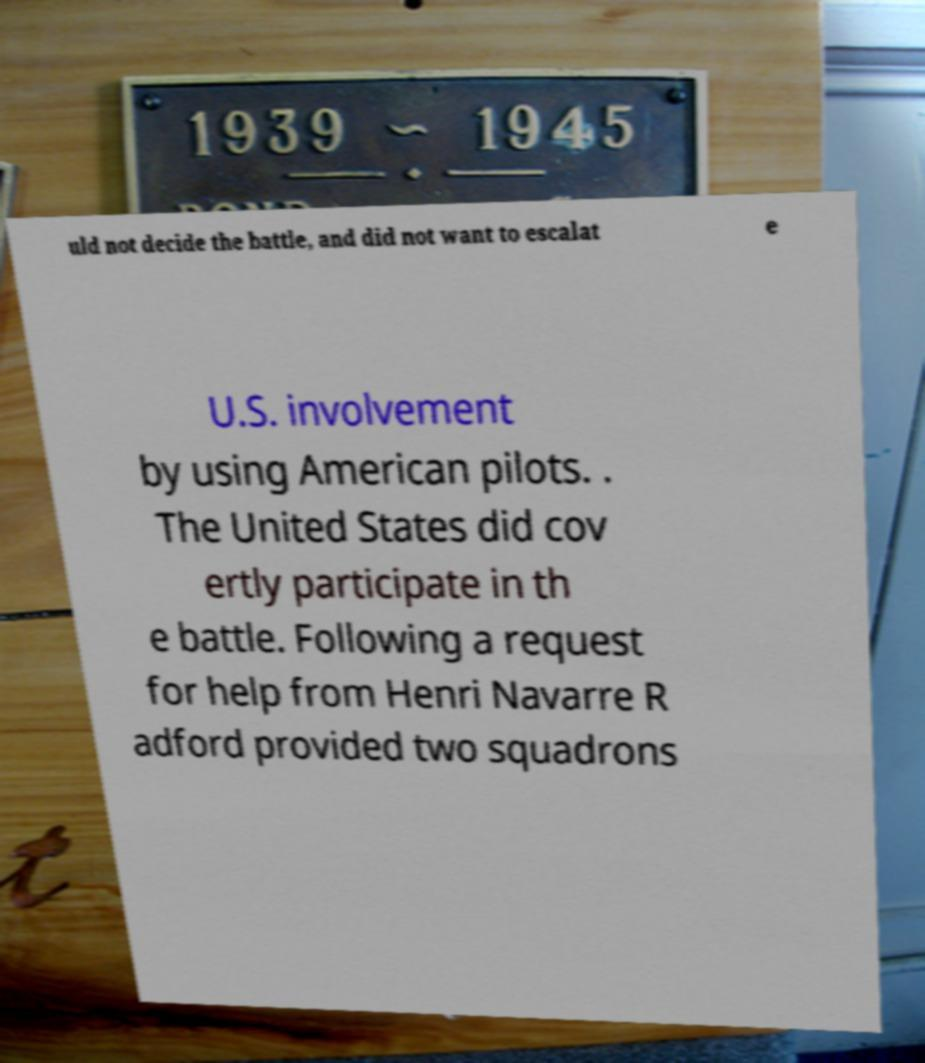I need the written content from this picture converted into text. Can you do that? uld not decide the battle, and did not want to escalat e U.S. involvement by using American pilots. . The United States did cov ertly participate in th e battle. Following a request for help from Henri Navarre R adford provided two squadrons 